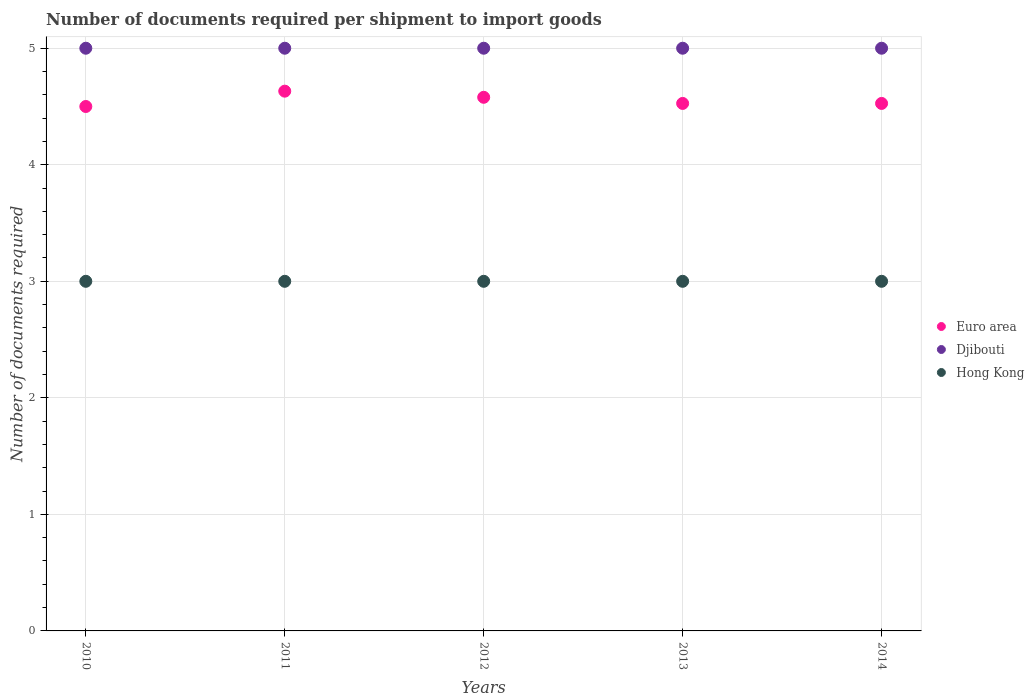How many different coloured dotlines are there?
Offer a very short reply. 3. Is the number of dotlines equal to the number of legend labels?
Offer a very short reply. Yes. What is the number of documents required per shipment to import goods in Euro area in 2010?
Offer a terse response. 4.5. Across all years, what is the maximum number of documents required per shipment to import goods in Hong Kong?
Your answer should be very brief. 3. In which year was the number of documents required per shipment to import goods in Hong Kong maximum?
Your answer should be compact. 2010. In which year was the number of documents required per shipment to import goods in Euro area minimum?
Provide a succinct answer. 2010. What is the total number of documents required per shipment to import goods in Hong Kong in the graph?
Ensure brevity in your answer.  15. What is the difference between the number of documents required per shipment to import goods in Euro area in 2014 and the number of documents required per shipment to import goods in Hong Kong in 2012?
Your response must be concise. 1.53. What is the average number of documents required per shipment to import goods in Euro area per year?
Provide a succinct answer. 4.55. In the year 2014, what is the difference between the number of documents required per shipment to import goods in Hong Kong and number of documents required per shipment to import goods in Euro area?
Keep it short and to the point. -1.53. What is the ratio of the number of documents required per shipment to import goods in Djibouti in 2011 to that in 2012?
Provide a short and direct response. 1. Is the number of documents required per shipment to import goods in Hong Kong in 2011 less than that in 2014?
Provide a short and direct response. No. Is the difference between the number of documents required per shipment to import goods in Hong Kong in 2012 and 2013 greater than the difference between the number of documents required per shipment to import goods in Euro area in 2012 and 2013?
Give a very brief answer. No. What is the difference between the highest and the second highest number of documents required per shipment to import goods in Hong Kong?
Ensure brevity in your answer.  0. What is the difference between the highest and the lowest number of documents required per shipment to import goods in Euro area?
Provide a succinct answer. 0.13. Does the number of documents required per shipment to import goods in Hong Kong monotonically increase over the years?
Your response must be concise. No. Is the number of documents required per shipment to import goods in Hong Kong strictly less than the number of documents required per shipment to import goods in Djibouti over the years?
Keep it short and to the point. Yes. How many dotlines are there?
Your answer should be very brief. 3. Does the graph contain any zero values?
Ensure brevity in your answer.  No. What is the title of the graph?
Your answer should be very brief. Number of documents required per shipment to import goods. Does "Egypt, Arab Rep." appear as one of the legend labels in the graph?
Provide a succinct answer. No. What is the label or title of the Y-axis?
Ensure brevity in your answer.  Number of documents required. What is the Number of documents required in Euro area in 2010?
Offer a terse response. 4.5. What is the Number of documents required of Euro area in 2011?
Your answer should be compact. 4.63. What is the Number of documents required of Djibouti in 2011?
Your answer should be compact. 5. What is the Number of documents required of Euro area in 2012?
Make the answer very short. 4.58. What is the Number of documents required of Hong Kong in 2012?
Your answer should be very brief. 3. What is the Number of documents required of Euro area in 2013?
Your answer should be compact. 4.53. What is the Number of documents required of Hong Kong in 2013?
Give a very brief answer. 3. What is the Number of documents required in Euro area in 2014?
Make the answer very short. 4.53. What is the Number of documents required of Djibouti in 2014?
Give a very brief answer. 5. Across all years, what is the maximum Number of documents required in Euro area?
Your answer should be very brief. 4.63. Across all years, what is the maximum Number of documents required of Djibouti?
Provide a succinct answer. 5. Across all years, what is the minimum Number of documents required in Hong Kong?
Give a very brief answer. 3. What is the total Number of documents required of Euro area in the graph?
Offer a very short reply. 22.76. What is the total Number of documents required in Djibouti in the graph?
Your answer should be compact. 25. What is the total Number of documents required in Hong Kong in the graph?
Offer a terse response. 15. What is the difference between the Number of documents required of Euro area in 2010 and that in 2011?
Provide a short and direct response. -0.13. What is the difference between the Number of documents required of Djibouti in 2010 and that in 2011?
Your answer should be very brief. 0. What is the difference between the Number of documents required of Hong Kong in 2010 and that in 2011?
Your response must be concise. 0. What is the difference between the Number of documents required of Euro area in 2010 and that in 2012?
Provide a succinct answer. -0.08. What is the difference between the Number of documents required of Djibouti in 2010 and that in 2012?
Provide a succinct answer. 0. What is the difference between the Number of documents required of Hong Kong in 2010 and that in 2012?
Provide a short and direct response. 0. What is the difference between the Number of documents required of Euro area in 2010 and that in 2013?
Your answer should be very brief. -0.03. What is the difference between the Number of documents required in Djibouti in 2010 and that in 2013?
Your answer should be very brief. 0. What is the difference between the Number of documents required of Euro area in 2010 and that in 2014?
Give a very brief answer. -0.03. What is the difference between the Number of documents required of Djibouti in 2010 and that in 2014?
Offer a terse response. 0. What is the difference between the Number of documents required of Euro area in 2011 and that in 2012?
Offer a terse response. 0.05. What is the difference between the Number of documents required of Djibouti in 2011 and that in 2012?
Offer a terse response. 0. What is the difference between the Number of documents required of Euro area in 2011 and that in 2013?
Make the answer very short. 0.11. What is the difference between the Number of documents required in Djibouti in 2011 and that in 2013?
Your response must be concise. 0. What is the difference between the Number of documents required in Hong Kong in 2011 and that in 2013?
Provide a short and direct response. 0. What is the difference between the Number of documents required of Euro area in 2011 and that in 2014?
Your answer should be very brief. 0.11. What is the difference between the Number of documents required in Djibouti in 2011 and that in 2014?
Your answer should be compact. 0. What is the difference between the Number of documents required in Hong Kong in 2011 and that in 2014?
Offer a very short reply. 0. What is the difference between the Number of documents required in Euro area in 2012 and that in 2013?
Provide a succinct answer. 0.05. What is the difference between the Number of documents required in Djibouti in 2012 and that in 2013?
Offer a terse response. 0. What is the difference between the Number of documents required in Euro area in 2012 and that in 2014?
Offer a very short reply. 0.05. What is the difference between the Number of documents required in Hong Kong in 2012 and that in 2014?
Your response must be concise. 0. What is the difference between the Number of documents required in Djibouti in 2013 and that in 2014?
Keep it short and to the point. 0. What is the difference between the Number of documents required in Euro area in 2010 and the Number of documents required in Hong Kong in 2011?
Offer a very short reply. 1.5. What is the difference between the Number of documents required of Euro area in 2010 and the Number of documents required of Hong Kong in 2013?
Ensure brevity in your answer.  1.5. What is the difference between the Number of documents required of Djibouti in 2010 and the Number of documents required of Hong Kong in 2014?
Provide a short and direct response. 2. What is the difference between the Number of documents required of Euro area in 2011 and the Number of documents required of Djibouti in 2012?
Make the answer very short. -0.37. What is the difference between the Number of documents required of Euro area in 2011 and the Number of documents required of Hong Kong in 2012?
Keep it short and to the point. 1.63. What is the difference between the Number of documents required of Euro area in 2011 and the Number of documents required of Djibouti in 2013?
Make the answer very short. -0.37. What is the difference between the Number of documents required of Euro area in 2011 and the Number of documents required of Hong Kong in 2013?
Offer a very short reply. 1.63. What is the difference between the Number of documents required of Djibouti in 2011 and the Number of documents required of Hong Kong in 2013?
Give a very brief answer. 2. What is the difference between the Number of documents required of Euro area in 2011 and the Number of documents required of Djibouti in 2014?
Keep it short and to the point. -0.37. What is the difference between the Number of documents required of Euro area in 2011 and the Number of documents required of Hong Kong in 2014?
Offer a very short reply. 1.63. What is the difference between the Number of documents required of Euro area in 2012 and the Number of documents required of Djibouti in 2013?
Your answer should be very brief. -0.42. What is the difference between the Number of documents required in Euro area in 2012 and the Number of documents required in Hong Kong in 2013?
Your answer should be compact. 1.58. What is the difference between the Number of documents required of Euro area in 2012 and the Number of documents required of Djibouti in 2014?
Offer a terse response. -0.42. What is the difference between the Number of documents required of Euro area in 2012 and the Number of documents required of Hong Kong in 2014?
Ensure brevity in your answer.  1.58. What is the difference between the Number of documents required in Euro area in 2013 and the Number of documents required in Djibouti in 2014?
Offer a very short reply. -0.47. What is the difference between the Number of documents required of Euro area in 2013 and the Number of documents required of Hong Kong in 2014?
Your response must be concise. 1.53. What is the difference between the Number of documents required in Djibouti in 2013 and the Number of documents required in Hong Kong in 2014?
Ensure brevity in your answer.  2. What is the average Number of documents required of Euro area per year?
Your response must be concise. 4.55. What is the average Number of documents required in Djibouti per year?
Ensure brevity in your answer.  5. What is the average Number of documents required in Hong Kong per year?
Keep it short and to the point. 3. In the year 2010, what is the difference between the Number of documents required of Euro area and Number of documents required of Djibouti?
Provide a succinct answer. -0.5. In the year 2010, what is the difference between the Number of documents required in Euro area and Number of documents required in Hong Kong?
Offer a very short reply. 1.5. In the year 2011, what is the difference between the Number of documents required in Euro area and Number of documents required in Djibouti?
Your answer should be very brief. -0.37. In the year 2011, what is the difference between the Number of documents required of Euro area and Number of documents required of Hong Kong?
Provide a short and direct response. 1.63. In the year 2011, what is the difference between the Number of documents required in Djibouti and Number of documents required in Hong Kong?
Your answer should be very brief. 2. In the year 2012, what is the difference between the Number of documents required of Euro area and Number of documents required of Djibouti?
Your answer should be very brief. -0.42. In the year 2012, what is the difference between the Number of documents required of Euro area and Number of documents required of Hong Kong?
Offer a very short reply. 1.58. In the year 2013, what is the difference between the Number of documents required of Euro area and Number of documents required of Djibouti?
Ensure brevity in your answer.  -0.47. In the year 2013, what is the difference between the Number of documents required of Euro area and Number of documents required of Hong Kong?
Give a very brief answer. 1.53. In the year 2013, what is the difference between the Number of documents required of Djibouti and Number of documents required of Hong Kong?
Offer a very short reply. 2. In the year 2014, what is the difference between the Number of documents required of Euro area and Number of documents required of Djibouti?
Ensure brevity in your answer.  -0.47. In the year 2014, what is the difference between the Number of documents required of Euro area and Number of documents required of Hong Kong?
Provide a succinct answer. 1.53. What is the ratio of the Number of documents required of Euro area in 2010 to that in 2011?
Provide a short and direct response. 0.97. What is the ratio of the Number of documents required of Euro area in 2010 to that in 2012?
Provide a succinct answer. 0.98. What is the ratio of the Number of documents required in Djibouti in 2010 to that in 2012?
Offer a terse response. 1. What is the ratio of the Number of documents required of Hong Kong in 2010 to that in 2012?
Make the answer very short. 1. What is the ratio of the Number of documents required in Euro area in 2010 to that in 2013?
Your answer should be compact. 0.99. What is the ratio of the Number of documents required of Euro area in 2010 to that in 2014?
Offer a terse response. 0.99. What is the ratio of the Number of documents required in Djibouti in 2010 to that in 2014?
Ensure brevity in your answer.  1. What is the ratio of the Number of documents required in Euro area in 2011 to that in 2012?
Offer a very short reply. 1.01. What is the ratio of the Number of documents required of Djibouti in 2011 to that in 2012?
Provide a short and direct response. 1. What is the ratio of the Number of documents required in Hong Kong in 2011 to that in 2012?
Offer a very short reply. 1. What is the ratio of the Number of documents required of Euro area in 2011 to that in 2013?
Make the answer very short. 1.02. What is the ratio of the Number of documents required in Djibouti in 2011 to that in 2013?
Provide a short and direct response. 1. What is the ratio of the Number of documents required of Hong Kong in 2011 to that in 2013?
Your answer should be very brief. 1. What is the ratio of the Number of documents required of Euro area in 2011 to that in 2014?
Ensure brevity in your answer.  1.02. What is the ratio of the Number of documents required in Djibouti in 2011 to that in 2014?
Provide a short and direct response. 1. What is the ratio of the Number of documents required in Hong Kong in 2011 to that in 2014?
Your answer should be very brief. 1. What is the ratio of the Number of documents required in Euro area in 2012 to that in 2013?
Your response must be concise. 1.01. What is the ratio of the Number of documents required in Djibouti in 2012 to that in 2013?
Ensure brevity in your answer.  1. What is the ratio of the Number of documents required of Euro area in 2012 to that in 2014?
Offer a very short reply. 1.01. What is the ratio of the Number of documents required in Euro area in 2013 to that in 2014?
Your answer should be compact. 1. What is the ratio of the Number of documents required in Hong Kong in 2013 to that in 2014?
Offer a terse response. 1. What is the difference between the highest and the second highest Number of documents required in Euro area?
Offer a terse response. 0.05. What is the difference between the highest and the second highest Number of documents required in Hong Kong?
Offer a very short reply. 0. What is the difference between the highest and the lowest Number of documents required of Euro area?
Ensure brevity in your answer.  0.13. What is the difference between the highest and the lowest Number of documents required of Djibouti?
Offer a very short reply. 0. What is the difference between the highest and the lowest Number of documents required of Hong Kong?
Provide a short and direct response. 0. 